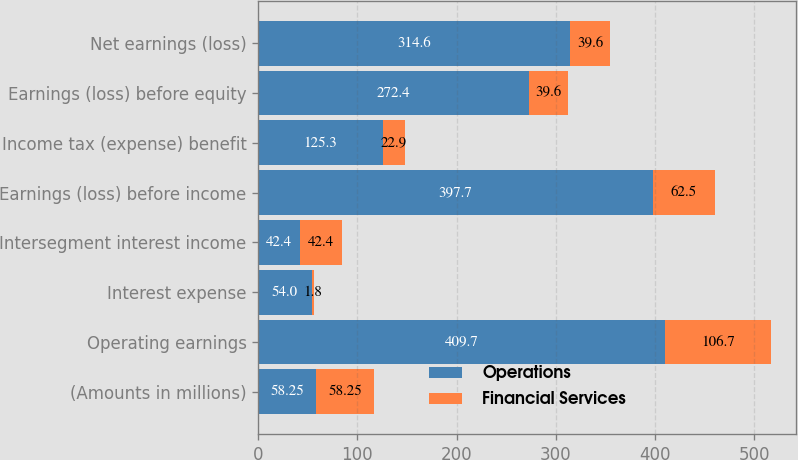Convert chart to OTSL. <chart><loc_0><loc_0><loc_500><loc_500><stacked_bar_chart><ecel><fcel>(Amounts in millions)<fcel>Operating earnings<fcel>Interest expense<fcel>Intersegment interest income<fcel>Earnings (loss) before income<fcel>Income tax (expense) benefit<fcel>Earnings (loss) before equity<fcel>Net earnings (loss)<nl><fcel>Operations<fcel>58.25<fcel>409.7<fcel>54<fcel>42.4<fcel>397.7<fcel>125.3<fcel>272.4<fcel>314.6<nl><fcel>Financial Services<fcel>58.25<fcel>106.7<fcel>1.8<fcel>42.4<fcel>62.5<fcel>22.9<fcel>39.6<fcel>39.6<nl></chart> 